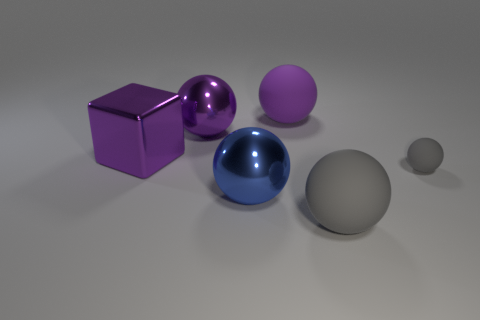There is a large thing that is the same color as the tiny rubber object; what material is it?
Your response must be concise. Rubber. Are there any big gray objects that have the same shape as the blue metal thing?
Provide a succinct answer. Yes. There is a tiny gray ball; what number of objects are to the right of it?
Keep it short and to the point. 0. What is the material of the big purple ball to the left of the large rubber sphere behind the tiny rubber thing?
Offer a very short reply. Metal. What is the material of the block that is the same size as the purple metallic sphere?
Offer a very short reply. Metal. Are there any yellow rubber spheres that have the same size as the blue metallic sphere?
Ensure brevity in your answer.  No. The large thing that is in front of the blue sphere is what color?
Ensure brevity in your answer.  Gray. There is a gray sphere on the left side of the tiny matte sphere; is there a big gray object that is left of it?
Keep it short and to the point. No. What number of other things are the same color as the big cube?
Make the answer very short. 2. Is the size of the sphere that is right of the large gray sphere the same as the metal ball that is on the left side of the blue ball?
Provide a short and direct response. No. 